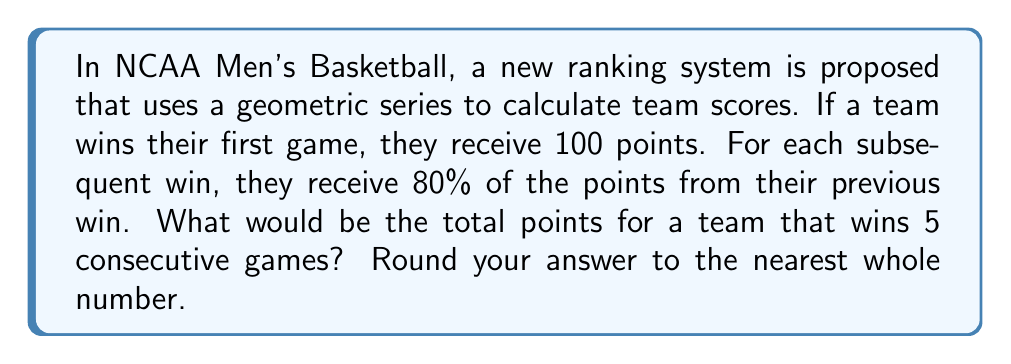Solve this math problem. Let's approach this step-by-step:

1) We're dealing with a geometric series where:
   - First term, $a = 100$
   - Common ratio, $r = 0.8$
   - Number of terms, $n = 5$

2) The formula for the sum of a geometric series is:

   $$S_n = \frac{a(1-r^n)}{1-r}$$

   Where $S_n$ is the sum of the first $n$ terms.

3) Let's substitute our values:

   $$S_5 = \frac{100(1-0.8^5)}{1-0.8}$$

4) Let's calculate $0.8^5$:
   
   $$0.8^5 = 0.32768$$

5) Now we can simplify our equation:

   $$S_5 = \frac{100(1-0.32768)}{0.2} = \frac{100(0.67232)}{0.2}$$

6) Simplifying further:

   $$S_5 = \frac{67.232}{0.2} = 336.16$$

7) Rounding to the nearest whole number:

   $$S_5 \approx 336$$
Answer: 336 